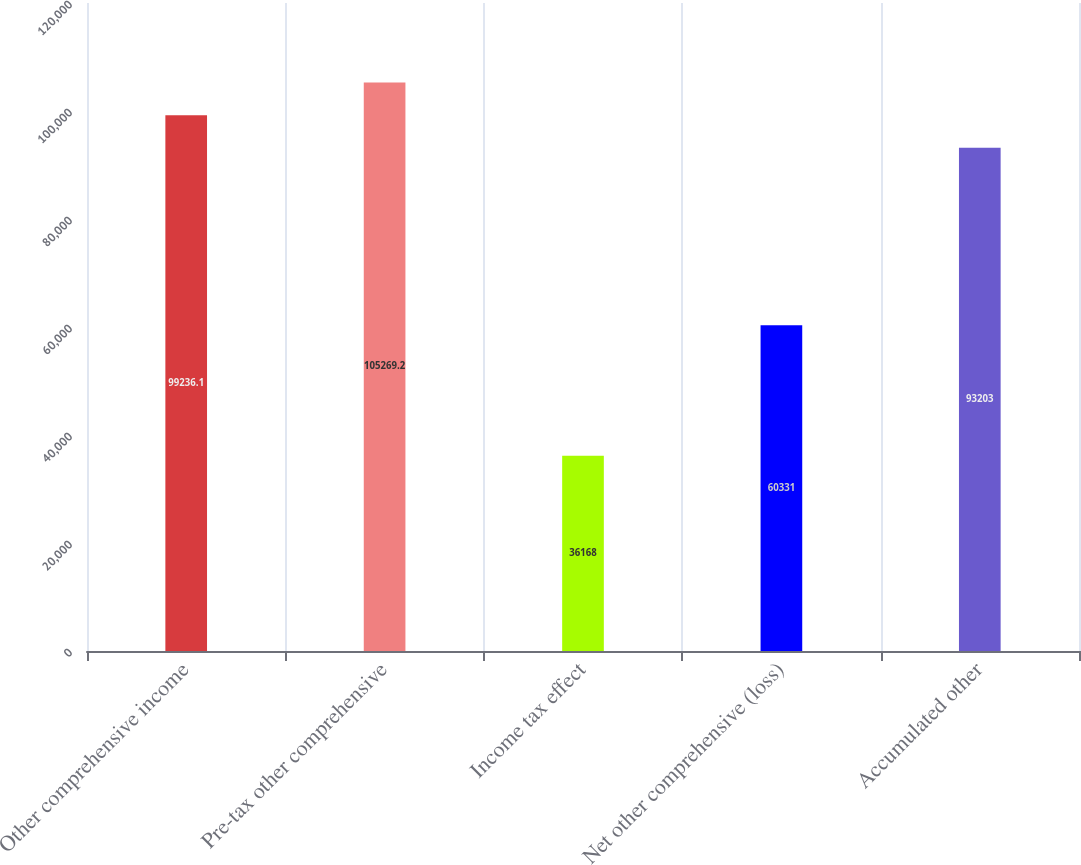<chart> <loc_0><loc_0><loc_500><loc_500><bar_chart><fcel>Other comprehensive income<fcel>Pre-tax other comprehensive<fcel>Income tax effect<fcel>Net other comprehensive (loss)<fcel>Accumulated other<nl><fcel>99236.1<fcel>105269<fcel>36168<fcel>60331<fcel>93203<nl></chart> 